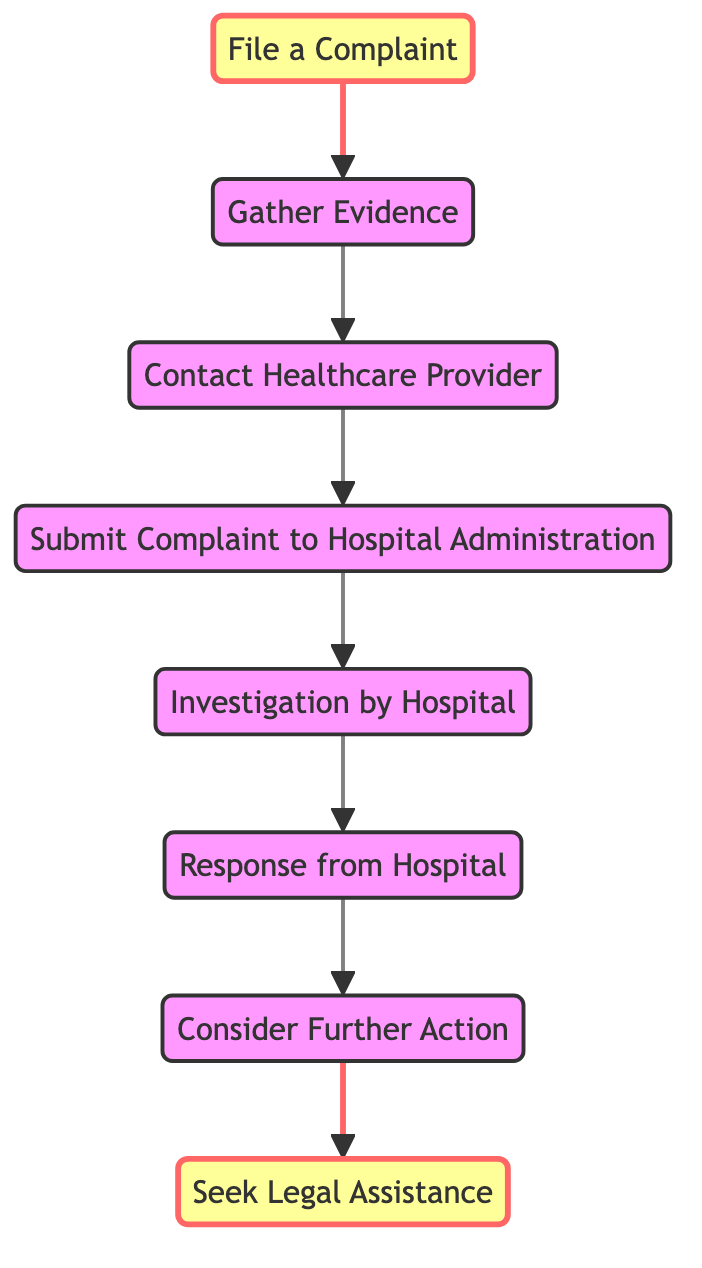What is the first step in the grievance procedure? The first step, as shown in the diagram, is to "File a Complaint." This is the starting point of the process presented.
Answer: File a Complaint How many nodes are present in the diagram? By counting each unique step described in the diagram, we see that there are a total of 8 nodes, each representing a distinct part of the grievance procedure.
Answer: 8 What action follows "Gather Evidence"? According to the flow of the diagram, the action that follows "Gather Evidence" is to "Contact Healthcare Provider." This is the next logical step in the procedure.
Answer: Contact Healthcare Provider Which party is responsible for the "Investigation"? The diagram indicates that the "Investigation" is conducted by the "Hospital." This shows the hospital's responsibility in the process after a complaint is submitted.
Answer: Hospital What happens after receiving the "Response from Hospital"? Following the "Response from Hospital," the next action specified in the diagram is to "Consider Further Action." This indicates that once a response is received, patients should evaluate their next steps.
Answer: Consider Further Action How many edges are present in the diagram? By analyzing the connections between each node, we see there are 7 edges, each representing the directional relationship between the steps in the grievance procedure.
Answer: 7 What is the last step in the grievance procedure according to the diagram? The final step depicted in the diagram is to "Seek Legal Assistance." This indicates that if other measures do not resolve the issue, seeking legal help is advisable.
Answer: Seek Legal Assistance What is the relationship between "Submit Complaint" and "Investigation"? The diagram shows a directional flow from "Submit Complaint" to "Investigation," meaning that after a complaint is submitted, an investigation follows as the next step.
Answer: Investigation What action must be taken before "Submit Complaint"? The diagram illustrates that "Contact Healthcare Provider" must be taken before "Submit Complaint," suggesting a necessary communication step before formal submission.
Answer: Contact Healthcare Provider 